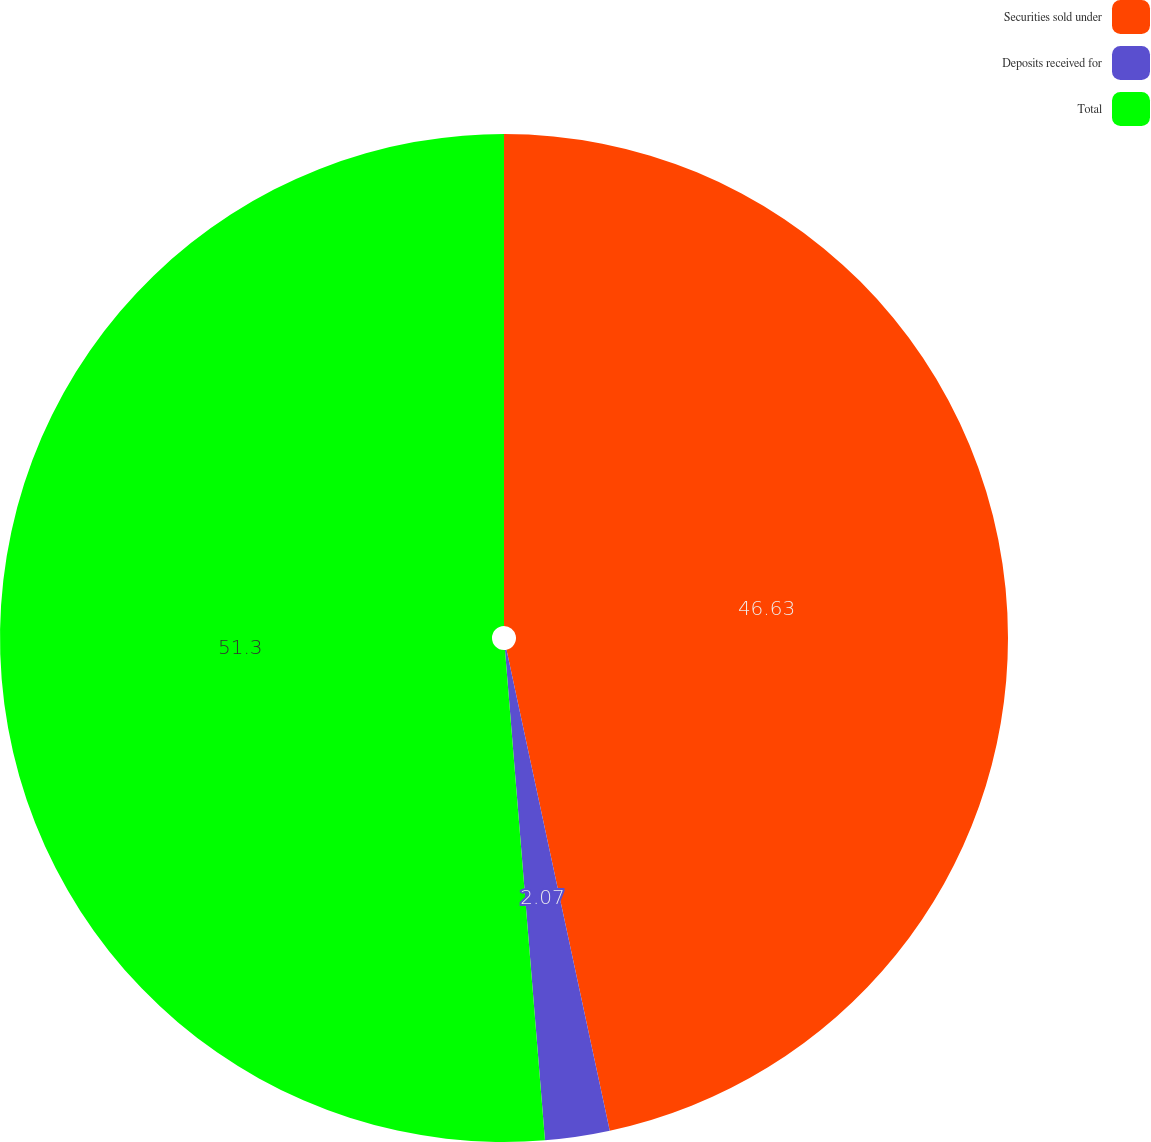Convert chart to OTSL. <chart><loc_0><loc_0><loc_500><loc_500><pie_chart><fcel>Securities sold under<fcel>Deposits received for<fcel>Total<nl><fcel>46.63%<fcel>2.07%<fcel>51.29%<nl></chart> 